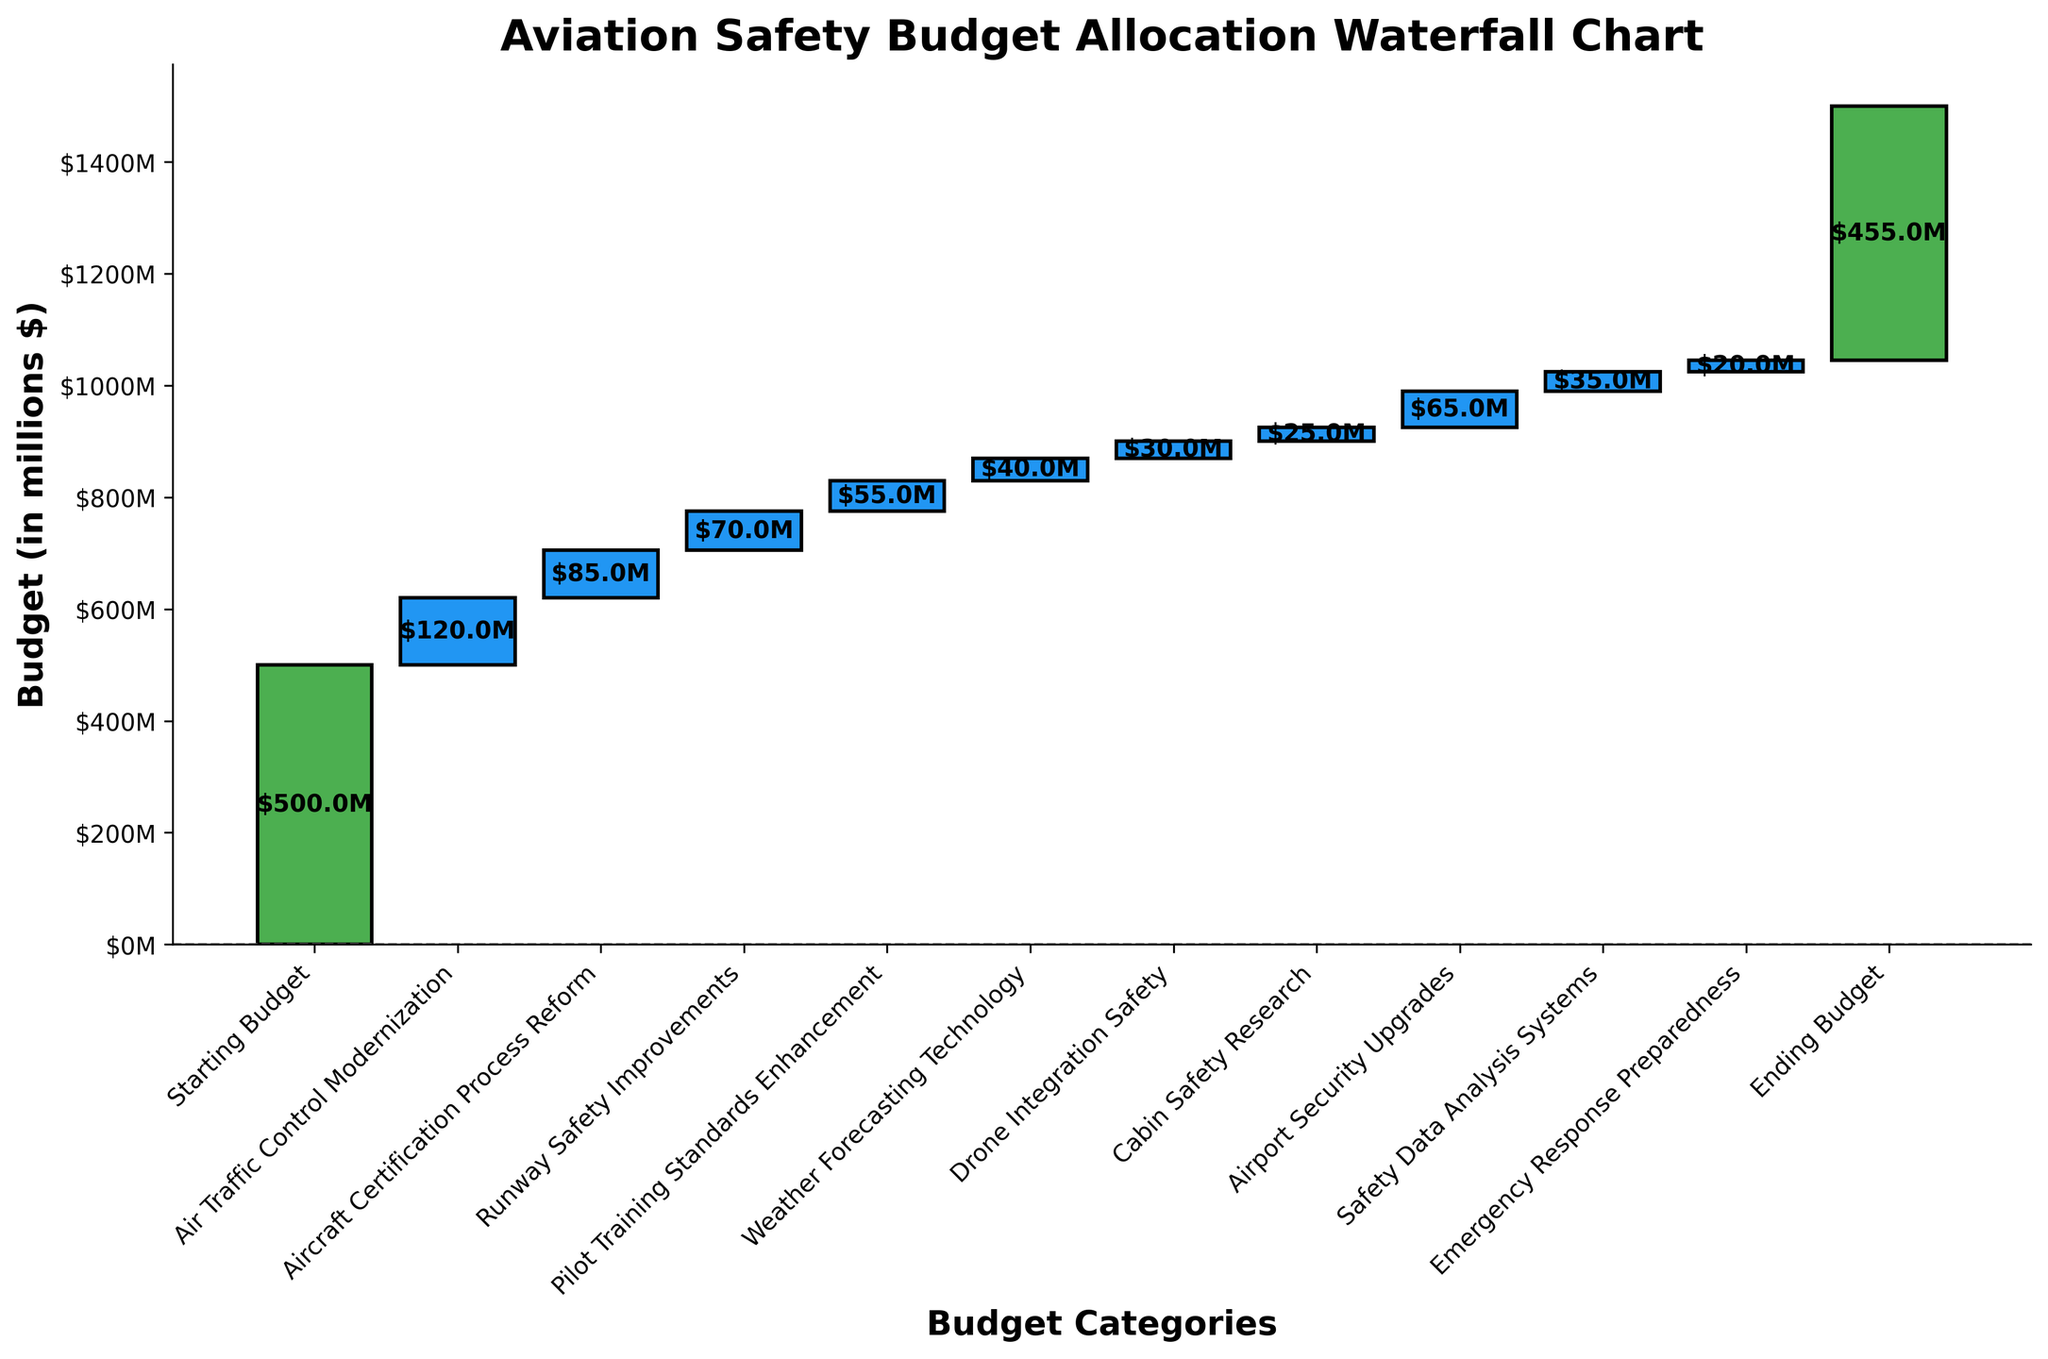What is the title of the figure? The title of the figure is prominently displayed at the top and is in bold. It states what the chart represents.
Answer: Aviation Safety Budget Allocation Waterfall Chart What is the total budget allocated for Airport Security Upgrades? To determine this, look at the bar labeled "Airport Security Upgrades" and locate the value on it.
Answer: $65M What is the cumulative budget after Air Traffic Control Modernization? Start with the initial budget and add the value of the Air Traffic Control Modernization to it. The cumulative sum is the initial budget plus the value of the first category.
Answer: $620M Which category has the smallest budget allocation? Identify the shortest bar within the categories (not the starting or ending budgets) and note its label.
Answer: Emergency Response Preparedness What is the total budget left after all allocations are made? This is the value shown at the end of the waterfall chart, after all categories have been accounted for.
Answer: $455M How much more budget is allocated to Aircraft Certification Process Reform compared to Weather Forecasting Technology? Look at each respective bar's value and subtract the smaller value (Weather Forecasting Technology) from the larger value (Aircraft Certification Process Reform).
Answer: $45M What are the values of the first and last budget categories, and how do they compare? Identify the values of "Starting Budget" and "Ending Budget," then describe the change. The first value is $500M and the last value is $455M, resulting in a decrease.
Answer: $500M, $455M, decrease by $45M Which category has a higher budget allocation, Pilot Training Standards Enhancement or Runway Safety Improvements, and by how much? Compare the heights of the bars labeled "Pilot Training Standards Enhancement" and "Runway Safety Improvements." Subtract the smaller value from the larger one.
Answer: Runway Safety Improvements by $15M What is the combined budget allocation for Cabin Safety Research and Drone Integration Safety? Sum the values of the bars labeled "Cabin Safety Research" and "Drone Integration Safety."
Answer: $55M How many budget categories are there (excluding the Starting and Ending Budget)? Count all the individual bars that correspond to specific programs, excluding the starting and ending bars.
Answer: 10 